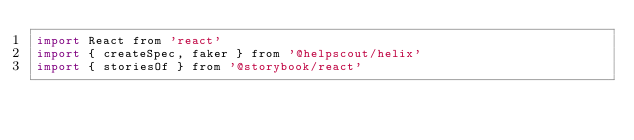<code> <loc_0><loc_0><loc_500><loc_500><_JavaScript_>import React from 'react'
import { createSpec, faker } from '@helpscout/helix'
import { storiesOf } from '@storybook/react'</code> 